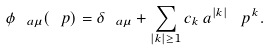<formula> <loc_0><loc_0><loc_500><loc_500>\phi _ { \ a \mu } ( \ p ) = \delta _ { \ a \mu } + \sum _ { | k | \geq 1 } c _ { k } \, a ^ { | k | } \, \ p ^ { k } .</formula> 